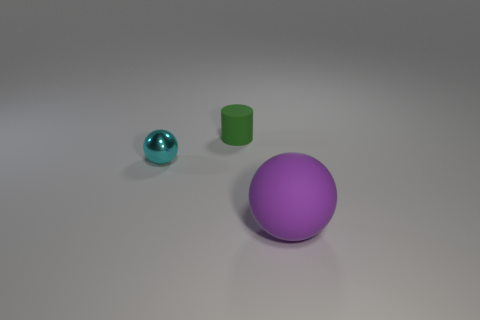Subtract all blue spheres. Subtract all brown blocks. How many spheres are left? 2 Add 1 green objects. How many objects exist? 4 Subtract all spheres. How many objects are left? 1 Add 1 matte things. How many matte things are left? 3 Add 3 shiny cylinders. How many shiny cylinders exist? 3 Subtract 0 cyan blocks. How many objects are left? 3 Subtract all big purple balls. Subtract all tiny blue shiny blocks. How many objects are left? 2 